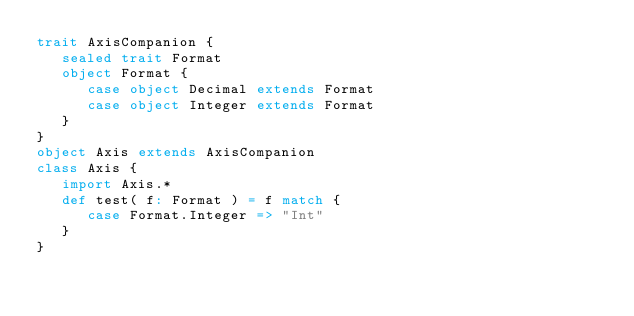<code> <loc_0><loc_0><loc_500><loc_500><_Scala_>trait AxisCompanion {
   sealed trait Format
   object Format {
      case object Decimal extends Format
      case object Integer extends Format
   }
}
object Axis extends AxisCompanion
class Axis {
   import Axis.*
   def test( f: Format ) = f match {
      case Format.Integer => "Int"
   }
}
</code> 